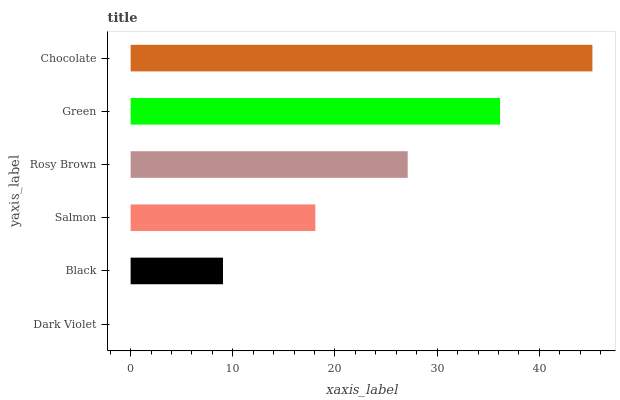Is Dark Violet the minimum?
Answer yes or no. Yes. Is Chocolate the maximum?
Answer yes or no. Yes. Is Black the minimum?
Answer yes or no. No. Is Black the maximum?
Answer yes or no. No. Is Black greater than Dark Violet?
Answer yes or no. Yes. Is Dark Violet less than Black?
Answer yes or no. Yes. Is Dark Violet greater than Black?
Answer yes or no. No. Is Black less than Dark Violet?
Answer yes or no. No. Is Rosy Brown the high median?
Answer yes or no. Yes. Is Salmon the low median?
Answer yes or no. Yes. Is Dark Violet the high median?
Answer yes or no. No. Is Chocolate the low median?
Answer yes or no. No. 